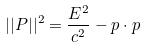<formula> <loc_0><loc_0><loc_500><loc_500>| | P | | ^ { 2 } = \frac { E ^ { 2 } } { c ^ { 2 } } - p \cdot p</formula> 